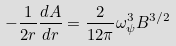Convert formula to latex. <formula><loc_0><loc_0><loc_500><loc_500>- \frac { 1 } { 2 r } \frac { d A } { d r } = \frac { 2 } { 1 2 \pi } { \omega } ^ { 3 } _ { \psi } B ^ { 3 / 2 }</formula> 